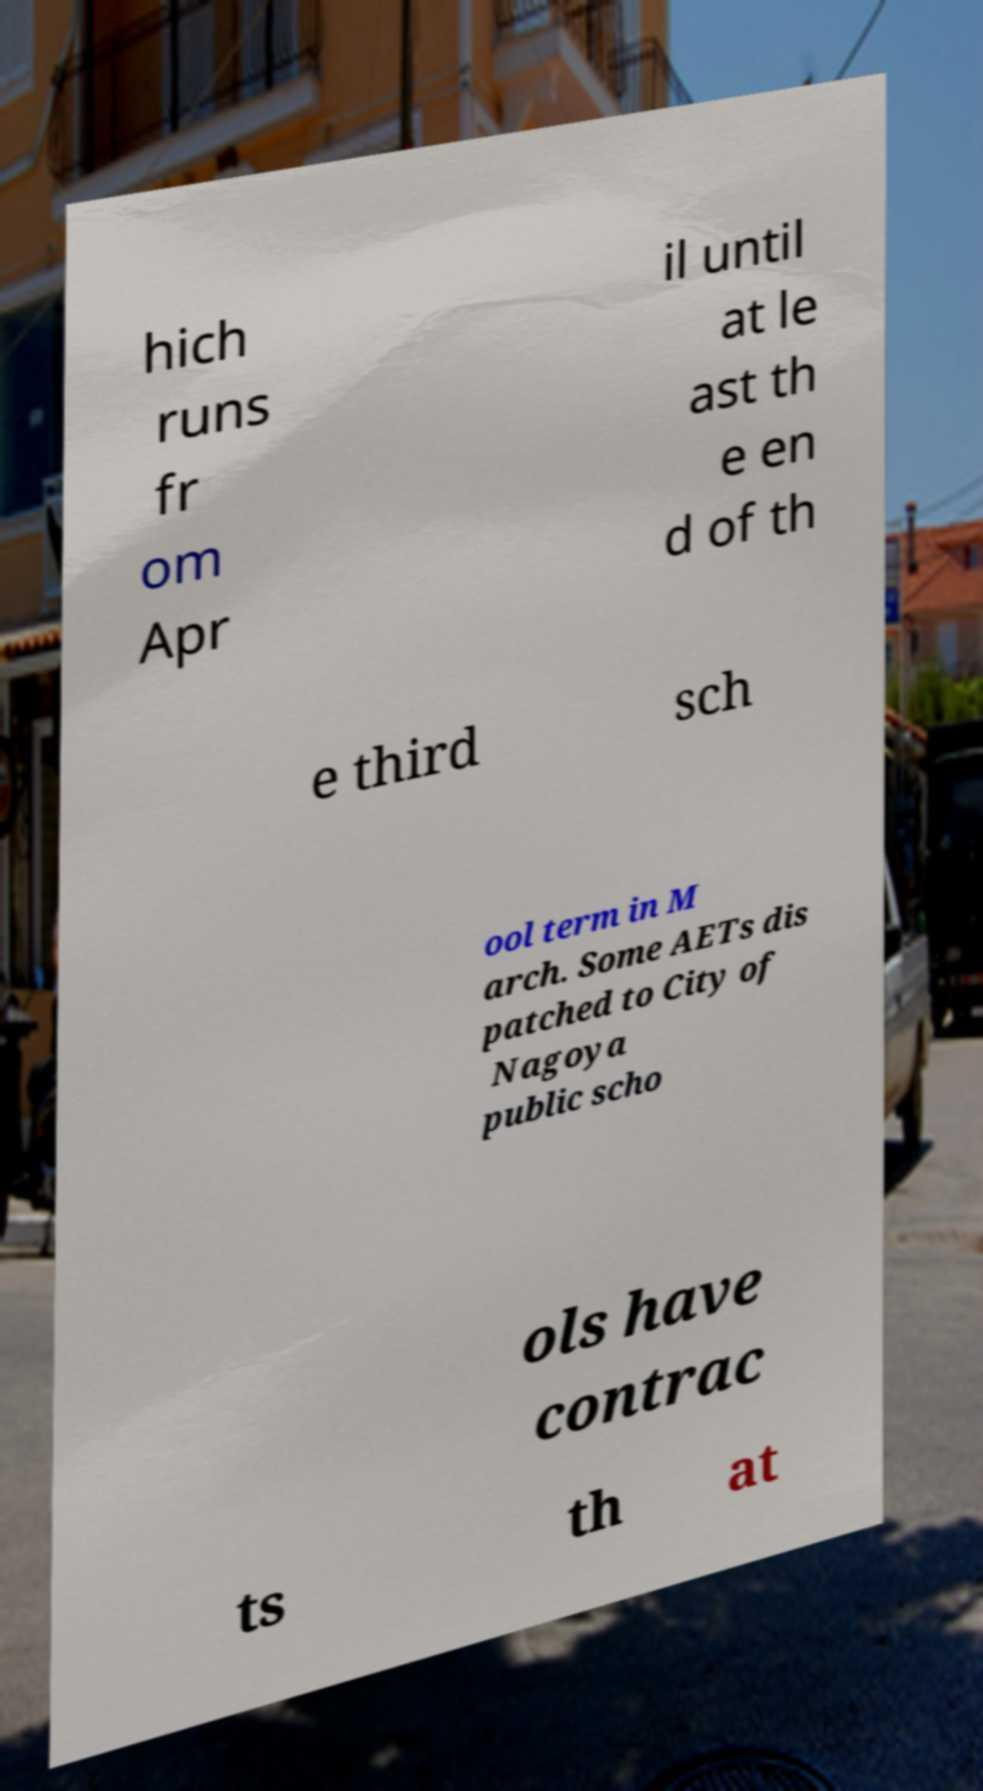Could you assist in decoding the text presented in this image and type it out clearly? hich runs fr om Apr il until at le ast th e en d of th e third sch ool term in M arch. Some AETs dis patched to City of Nagoya public scho ols have contrac ts th at 